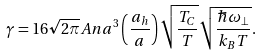Convert formula to latex. <formula><loc_0><loc_0><loc_500><loc_500>\gamma = 1 6 \sqrt { 2 \pi } A n a ^ { 3 } \left ( \frac { a _ { h } } { a } \right ) \sqrt { \frac { T _ { C } } { T } } \sqrt { \frac { \hbar { \omega } _ { \perp } } { k _ { B } T } } .</formula> 